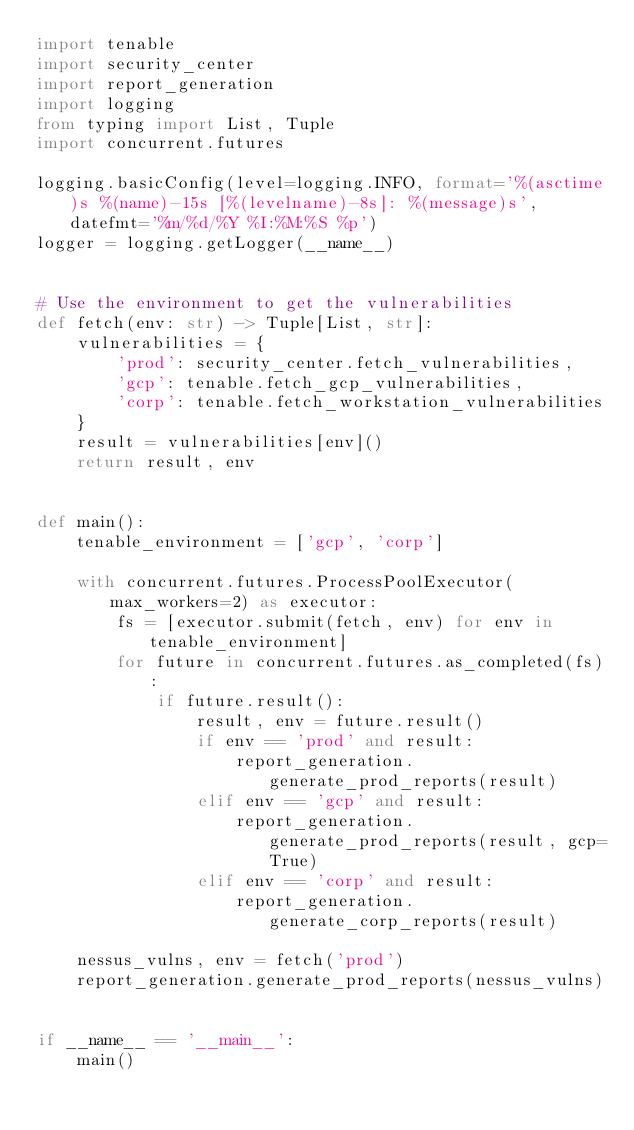Convert code to text. <code><loc_0><loc_0><loc_500><loc_500><_Python_>import tenable
import security_center
import report_generation
import logging
from typing import List, Tuple
import concurrent.futures

logging.basicConfig(level=logging.INFO, format='%(asctime)s %(name)-15s [%(levelname)-8s]: %(message)s', datefmt='%m/%d/%Y %I:%M:%S %p')
logger = logging.getLogger(__name__)


# Use the environment to get the vulnerabilities
def fetch(env: str) -> Tuple[List, str]:
    vulnerabilities = {
        'prod': security_center.fetch_vulnerabilities,
        'gcp': tenable.fetch_gcp_vulnerabilities,
        'corp': tenable.fetch_workstation_vulnerabilities
    }
    result = vulnerabilities[env]()
    return result, env


def main():
    tenable_environment = ['gcp', 'corp']

    with concurrent.futures.ProcessPoolExecutor(max_workers=2) as executor:
        fs = [executor.submit(fetch, env) for env in tenable_environment]
        for future in concurrent.futures.as_completed(fs):
            if future.result():
                result, env = future.result()
                if env == 'prod' and result:
                    report_generation.generate_prod_reports(result)
                elif env == 'gcp' and result:
                    report_generation.generate_prod_reports(result, gcp=True)
                elif env == 'corp' and result:
                    report_generation.generate_corp_reports(result)

    nessus_vulns, env = fetch('prod')
    report_generation.generate_prod_reports(nessus_vulns)


if __name__ == '__main__':
    main()
</code> 